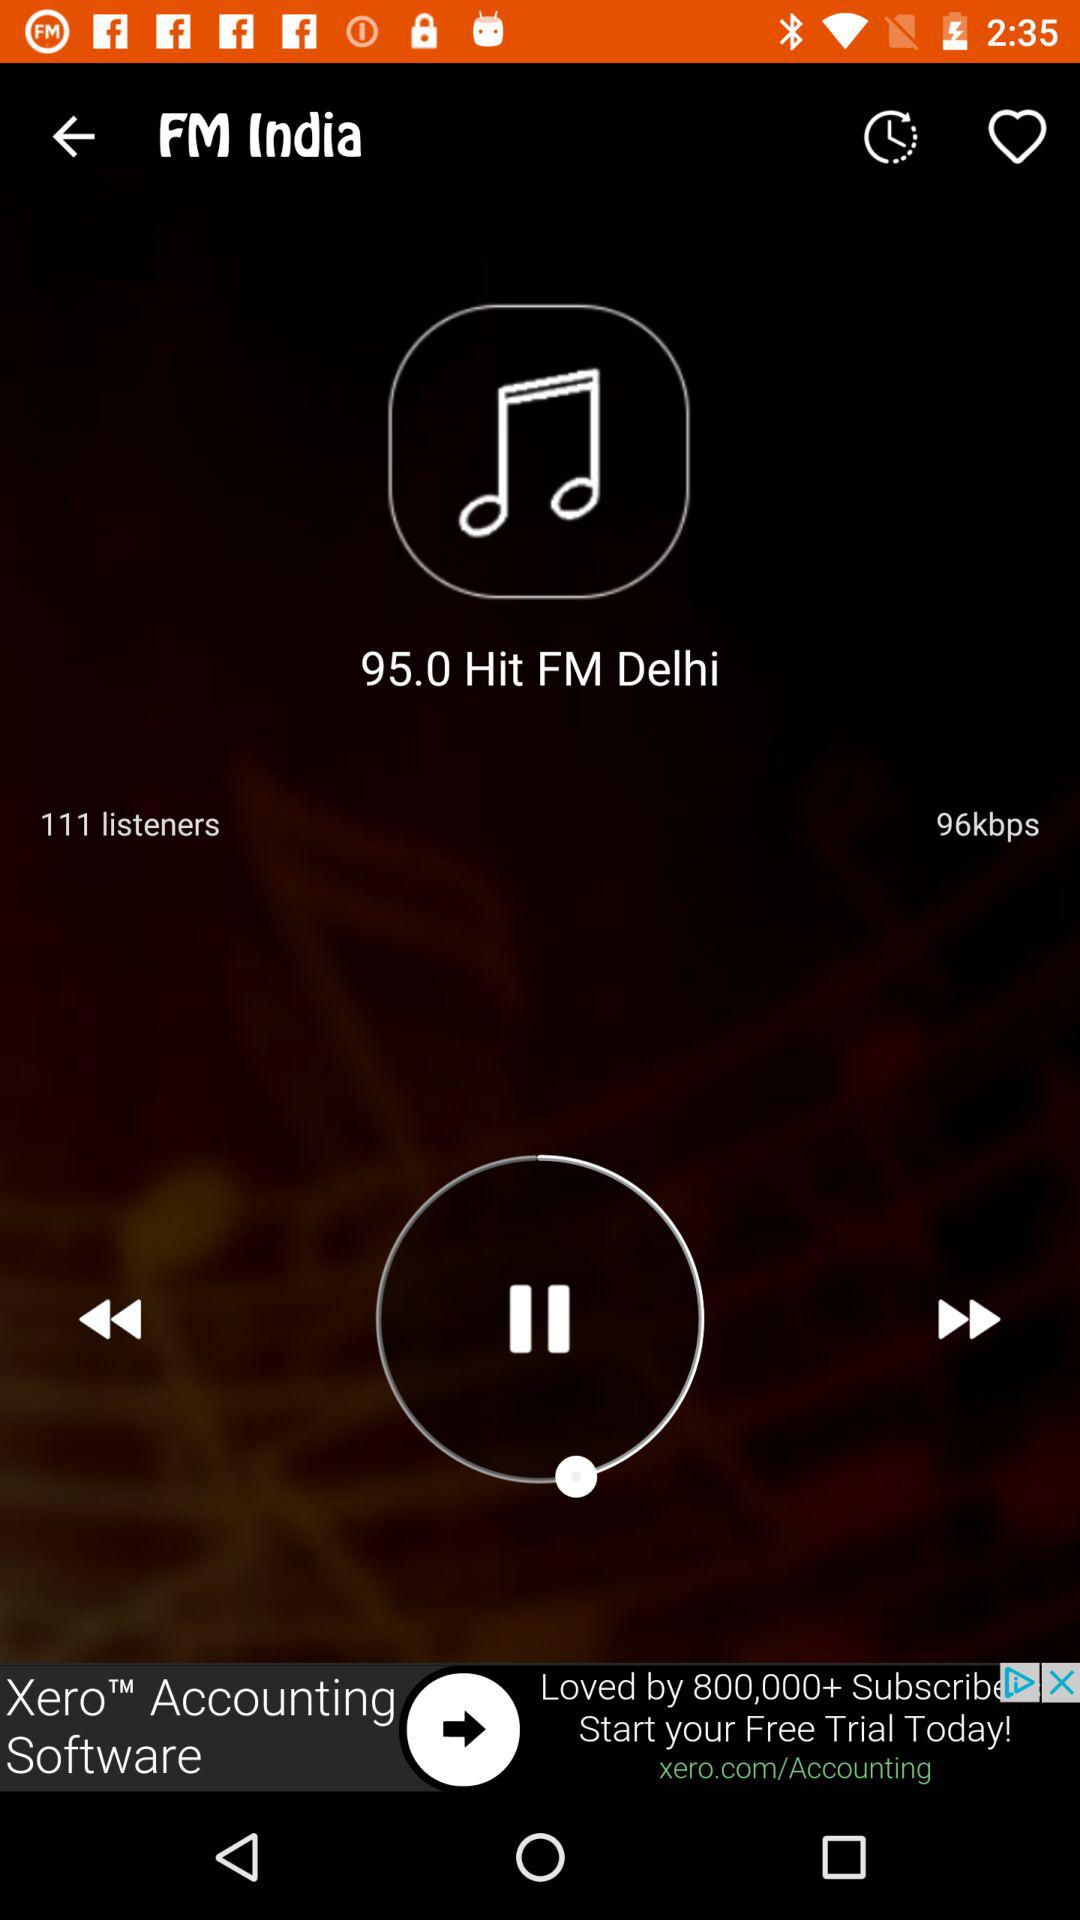How many listeners in total are listening? The total number of listeners is 111. 